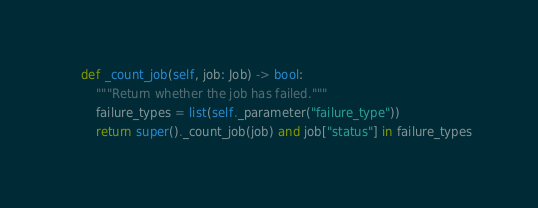<code> <loc_0><loc_0><loc_500><loc_500><_Python_>
    def _count_job(self, job: Job) -> bool:
        """Return whether the job has failed."""
        failure_types = list(self._parameter("failure_type"))
        return super()._count_job(job) and job["status"] in failure_types
</code> 